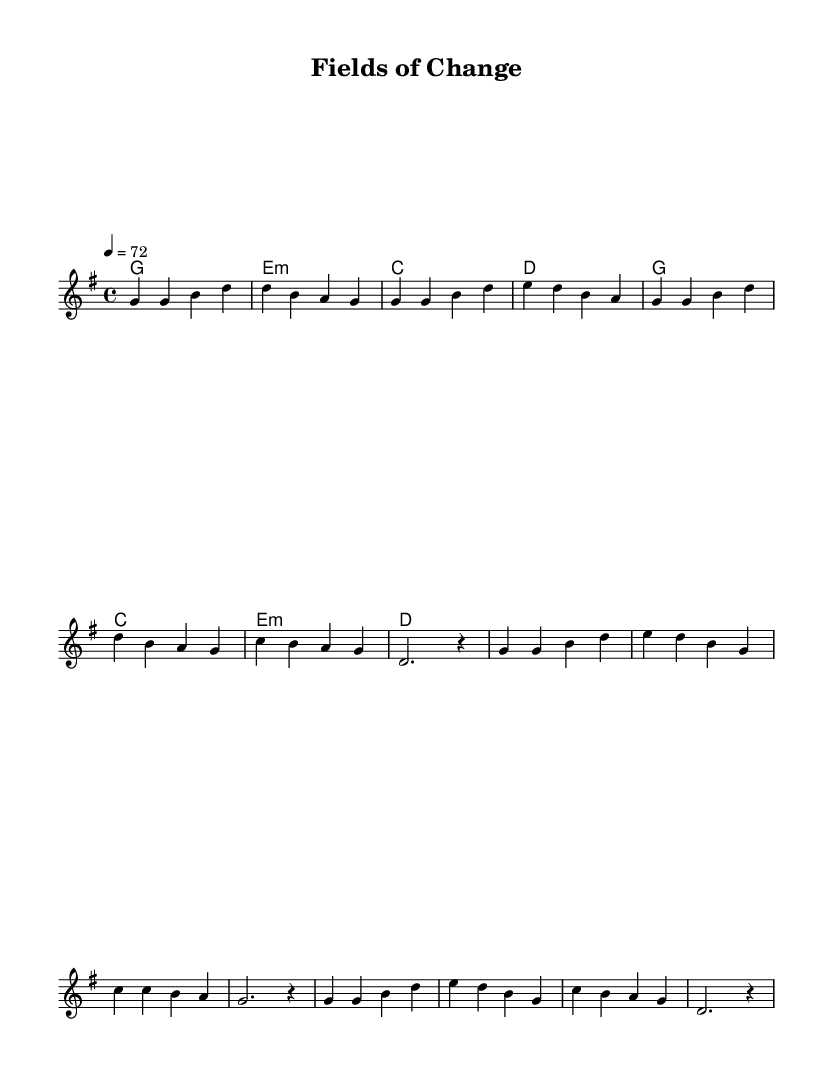What is the key signature of this music? The key signature indicated in the music is G major, which has one sharp (F#). This is evidenced by the "g \major" notation in the global settings of the code.
Answer: G major What is the time signature of this music? The time signature is 4/4, which is shown in the global section of the code as "\time 4/4". This indicates that there are four beats in each measure.
Answer: 4/4 What is the tempo of the piece? The tempo is set at 72 beats per minute, as indicated by "\tempo 4 = 72" in the global section of the code. This tells musicians how quickly to play the piece.
Answer: 72 How many measures are in the verse section? The verse section contains eight measures, as evidenced by counting the measures in the melody block that are specific to the verse.
Answer: 8 What is the first chord of the chorus? The first chord of the chorus is G major, which is found at the start of the chorus in the harmonies section where it shows "g1" indicating this chord is played over the first measure of the chorus.
Answer: G What is the last note of the melody in the verse? The last note of the melody in the verse is a rest, which is indicated by "r4" at the end of the verse section, showing no pitch for that measure.
Answer: rest How many unique chords are present in the music? There are four unique chords present in the music: G major, E minor, C major, and D major. This can be determined by observing the distinct chords listed in the harmonies section of the code.
Answer: 4 